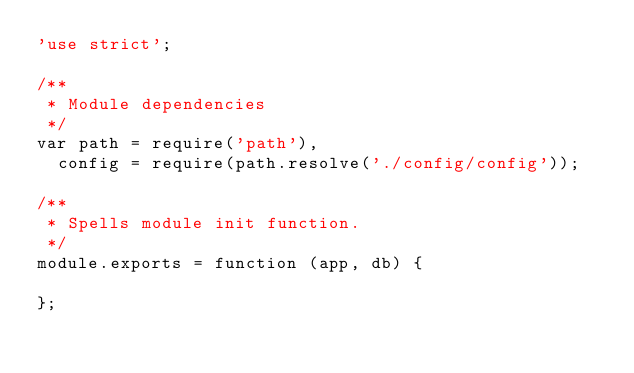Convert code to text. <code><loc_0><loc_0><loc_500><loc_500><_JavaScript_>'use strict';

/**
 * Module dependencies
 */
var path = require('path'),
  config = require(path.resolve('./config/config'));

/**
 * Spells module init function.
 */
module.exports = function (app, db) {

};
</code> 